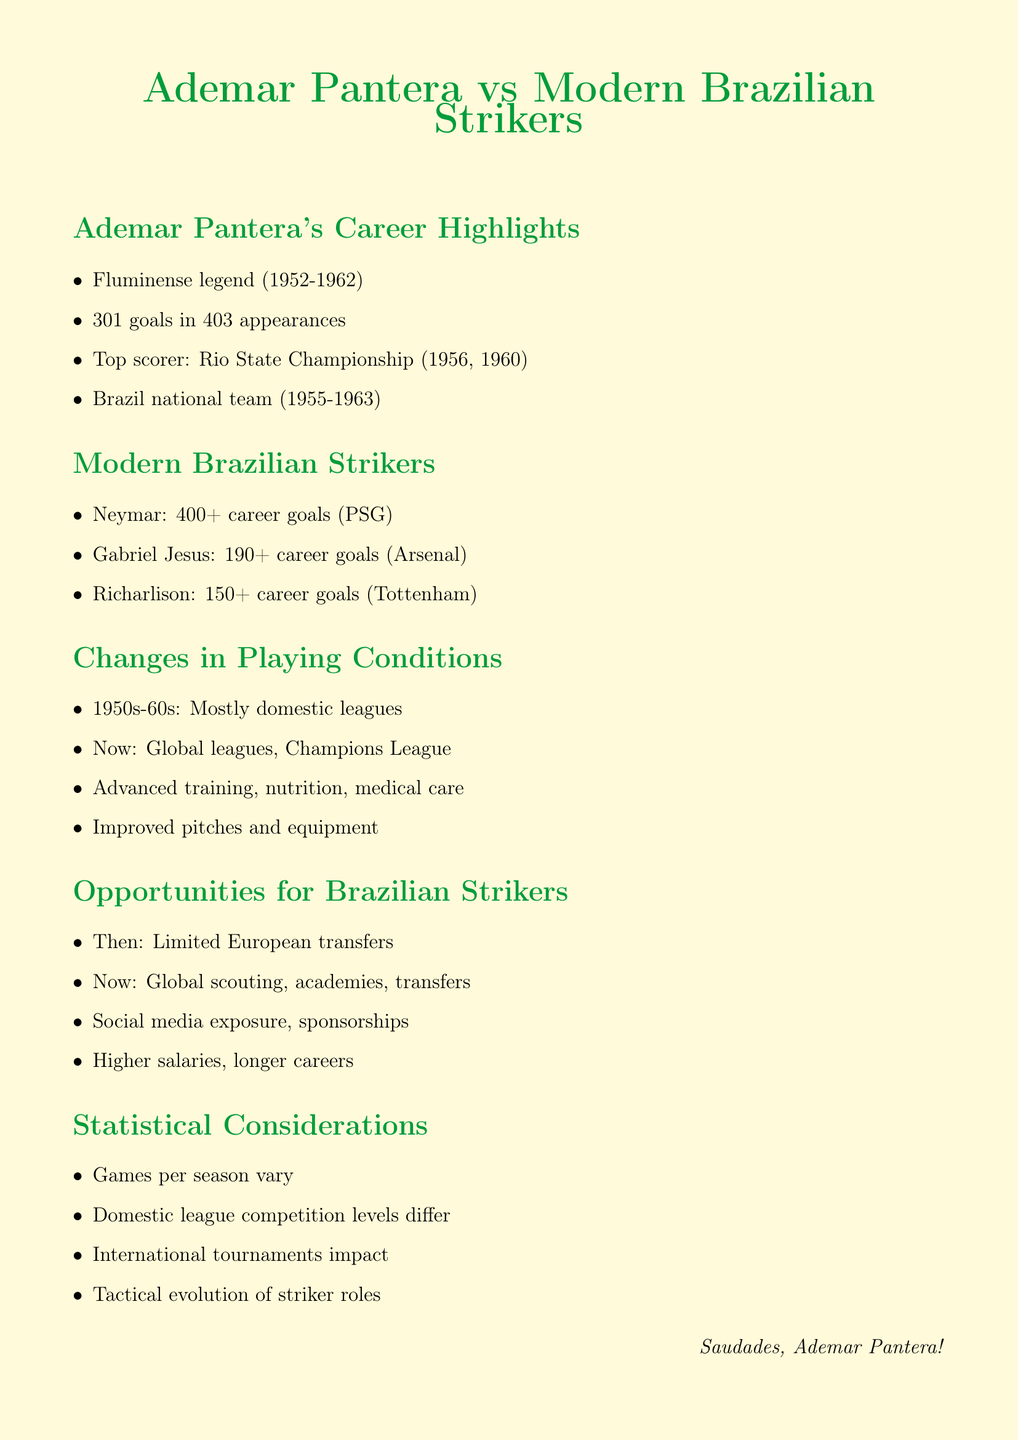What years did Ademar Pantera play for Fluminense? The document states that he played for Fluminense from 1952 to 1962.
Answer: 1952 to 1962 How many goals did Ademar Pantera score for Fluminense? According to the document, he scored 301 goals in 403 appearances for Fluminense.
Answer: 301 goals Which championship did Ademar Pantera top score in? The document mentions he was the top scorer in the Rio State Championship in 1956 and 1960.
Answer: Rio State Championship What club does Neymar play for? Neymar is stated in the document to play for Paris Saint-Germain.
Answer: Paris Saint-Germain How many career goals does Richarlison have? The document indicates that Richarlison has 150+ career goals.
Answer: 150+ What is the main difference in playing conditions between the 1950s-60s and the modern era? The document notes that the 1950s-60s had mostly domestic leagues while the modern era has global leagues and Champions League.
Answer: Global leagues, Champions League What opportunities were limited for Brazilian strikers in the 1950s-60s? It mentions that there were limited transfers to European clubs during that time.
Answer: Limited transfers to European clubs What factor has contributed to higher salaries for modern Brazilian strikers? The document indicates that better medical care is a factor contributing to higher salaries and longer careers.
Answer: Better medical care What is one of the statistical considerations when comparing career statistics? The document states that the different number of games played per season is a statistical consideration.
Answer: Different number of games played per season 